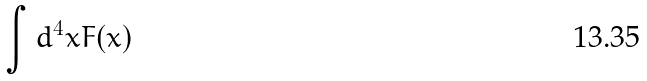Convert formula to latex. <formula><loc_0><loc_0><loc_500><loc_500>\int d ^ { 4 } x F ( x )</formula> 